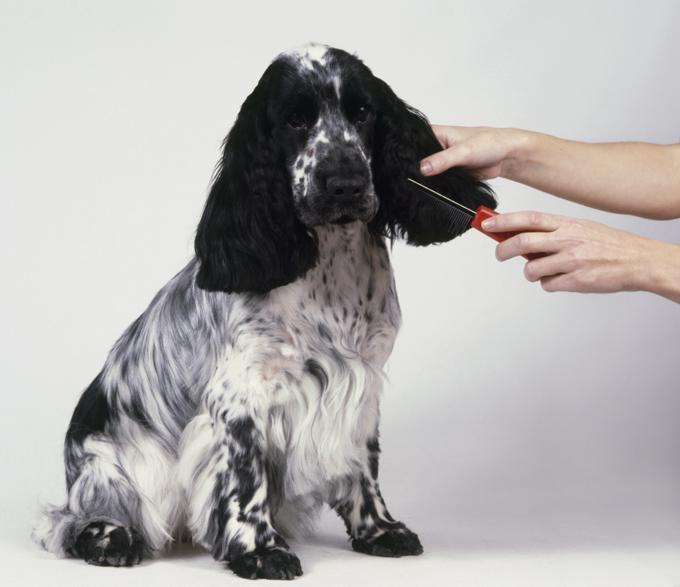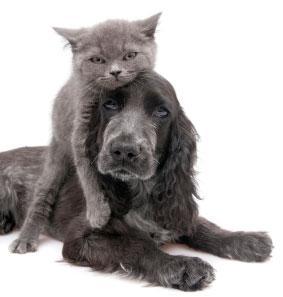The first image is the image on the left, the second image is the image on the right. Considering the images on both sides, is "Each set of images contains exactly two animals." valid? Answer yes or no. No. The first image is the image on the left, the second image is the image on the right. Evaluate the accuracy of this statement regarding the images: "The image on the right contains a dark colored dog.". Is it true? Answer yes or no. Yes. 